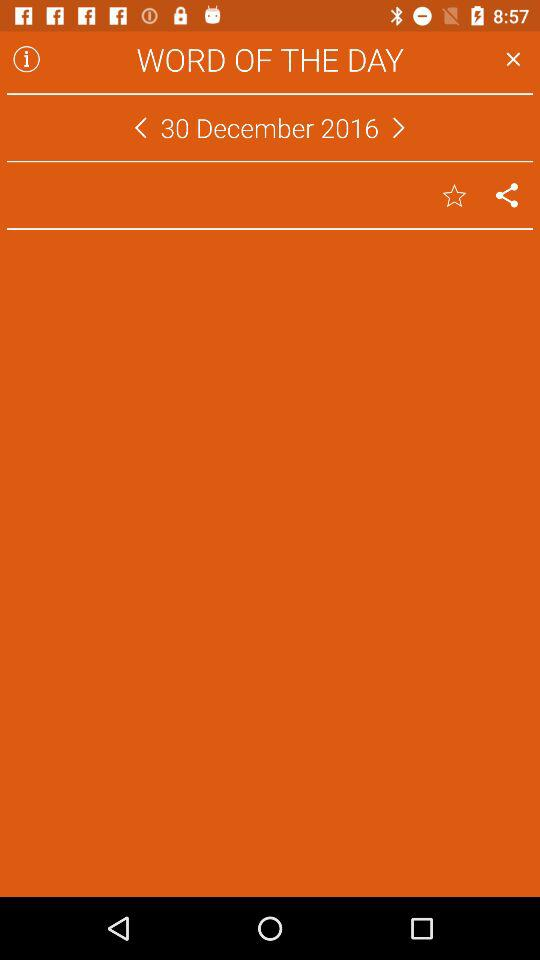What is the given date? The given date is December 30, 2016. 